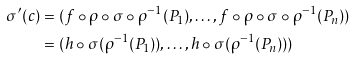Convert formula to latex. <formula><loc_0><loc_0><loc_500><loc_500>\sigma ^ { \prime } ( c ) & = ( f \circ \rho \circ \sigma \circ \rho ^ { - 1 } ( P _ { 1 } ) , \dots , f \circ \rho \circ \sigma \circ \rho ^ { - 1 } ( P _ { n } ) ) \\ & = ( h \circ \sigma ( \rho ^ { - 1 } ( P _ { 1 } ) ) , \dots , h \circ \sigma ( \rho ^ { - 1 } ( P _ { n } ) ) )</formula> 